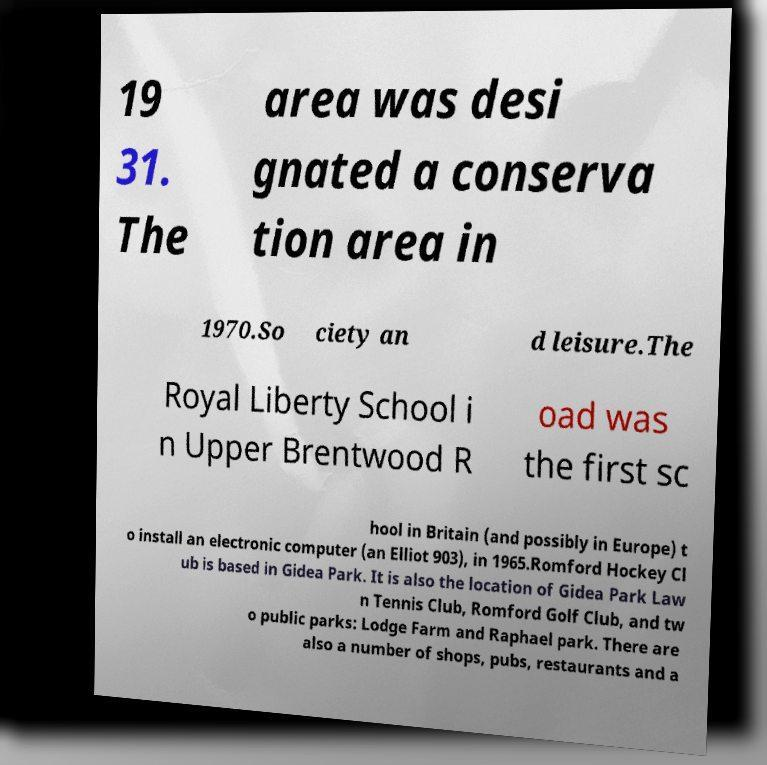What messages or text are displayed in this image? I need them in a readable, typed format. 19 31. The area was desi gnated a conserva tion area in 1970.So ciety an d leisure.The Royal Liberty School i n Upper Brentwood R oad was the first sc hool in Britain (and possibly in Europe) t o install an electronic computer (an Elliot 903), in 1965.Romford Hockey Cl ub is based in Gidea Park. It is also the location of Gidea Park Law n Tennis Club, Romford Golf Club, and tw o public parks: Lodge Farm and Raphael park. There are also a number of shops, pubs, restaurants and a 